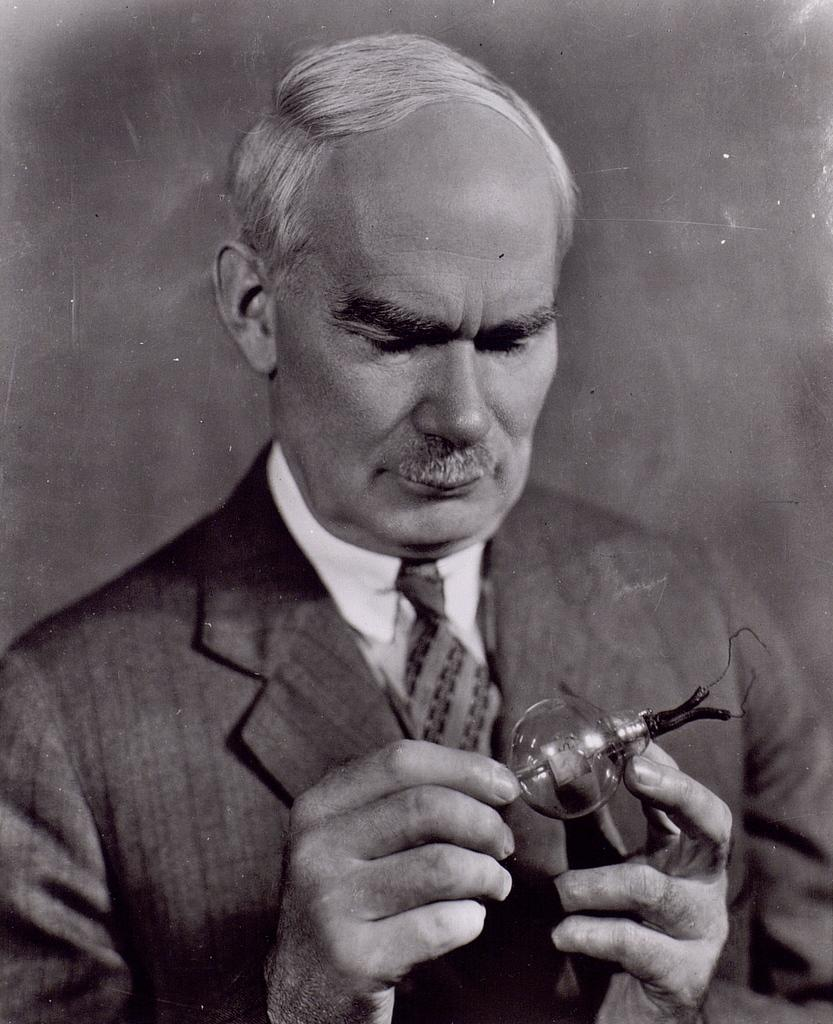Who is present in the image? There is a person in the image. What is the person wearing? The person is wearing a suit. Can you describe any accessories the person is wearing? The person is wearing an object, which could be a watch, a tie, or any other accessory. What songs can be heard playing in the background of the image? There is no audio or sound present in the image, so it is not possible to determine what songs might be heard. 